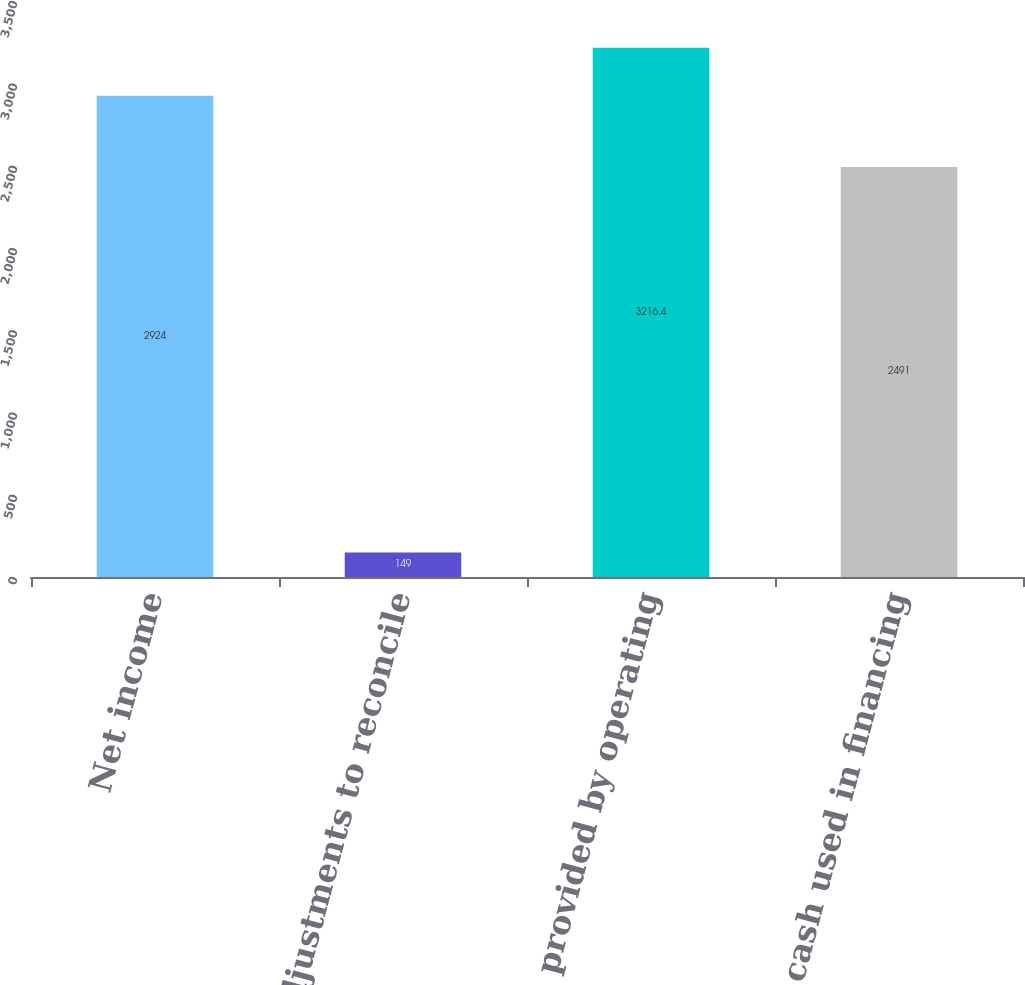Convert chart. <chart><loc_0><loc_0><loc_500><loc_500><bar_chart><fcel>Net income<fcel>Net adjustments to reconcile<fcel>Net cash provided by operating<fcel>Net cash used in financing<nl><fcel>2924<fcel>149<fcel>3216.4<fcel>2491<nl></chart> 